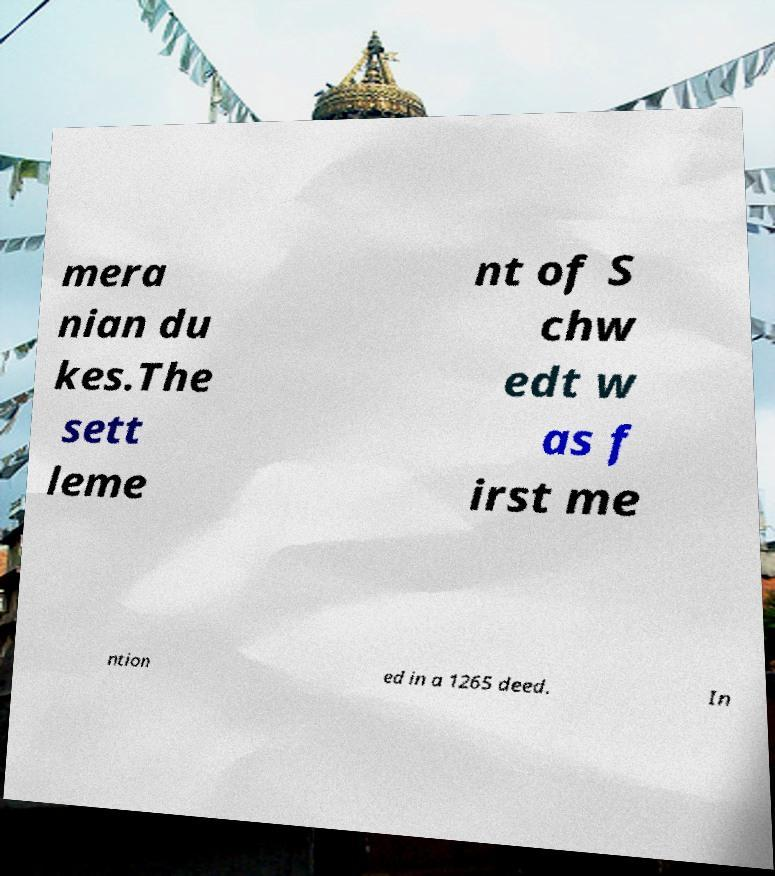Could you assist in decoding the text presented in this image and type it out clearly? mera nian du kes.The sett leme nt of S chw edt w as f irst me ntion ed in a 1265 deed. In 